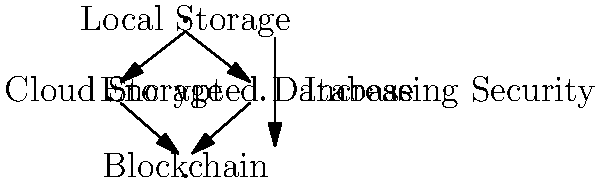Based on the hierarchical diagram representing different data storage methods for court transcripts, which method offers the highest level of security and why might it be particularly relevant for a tech-savvy transcriptionist working with AI tools in a courtroom setting? To answer this question, let's analyze the diagram and consider the security implications of each storage method:

1. Local Storage: This is at the top of the hierarchy, suggesting it's the least secure option. Local storage is vulnerable to physical theft, hardware failure, and unauthorized access if the device is compromised.

2. Cloud Storage: Moving down the hierarchy, cloud storage offers better security than local storage. It provides off-site backup and often includes encryption in transit and at rest. However, it may still be vulnerable to data breaches or unauthorized access through compromised credentials.

3. Encrypted Database: This method offers a higher level of security than cloud storage. Encryption adds an extra layer of protection, making it difficult for unauthorized parties to access or understand the data even if they gain access to the storage system.

4. Blockchain: At the bottom of the hierarchy, blockchain technology offers the highest level of security. It provides:
   - Immutability: Once data is recorded, it cannot be altered without consensus from the network.
   - Decentralization: No single point of failure or control.
   - Cryptographic security: Each block is cryptographically linked to the previous one, making it extremely difficult to tamper with the data.
   - Transparency: All transactions are visible to authorized parties, creating an auditable trail.

For a tech-savvy transcriptionist working with AI tools in a courtroom, blockchain storage would be particularly relevant because:
- It ensures the integrity of court transcripts, preventing any unauthorized alterations.
- It provides a transparent and auditable record of all changes made to the transcripts.
- It can securely store and manage the large amounts of data generated by AI transcription tools.
- It allows for secure sharing of transcripts with authorized parties while maintaining strict access controls.
- It can integrate with AI systems to create a tamper-proof record of AI-assisted transcriptions, which is crucial for maintaining the court's trust in these new technologies.
Answer: Blockchain, due to its immutability, decentralization, and cryptographic security. 